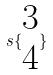Convert formula to latex. <formula><loc_0><loc_0><loc_500><loc_500>s \{ \begin{matrix} 3 \\ 4 \end{matrix} \}</formula> 